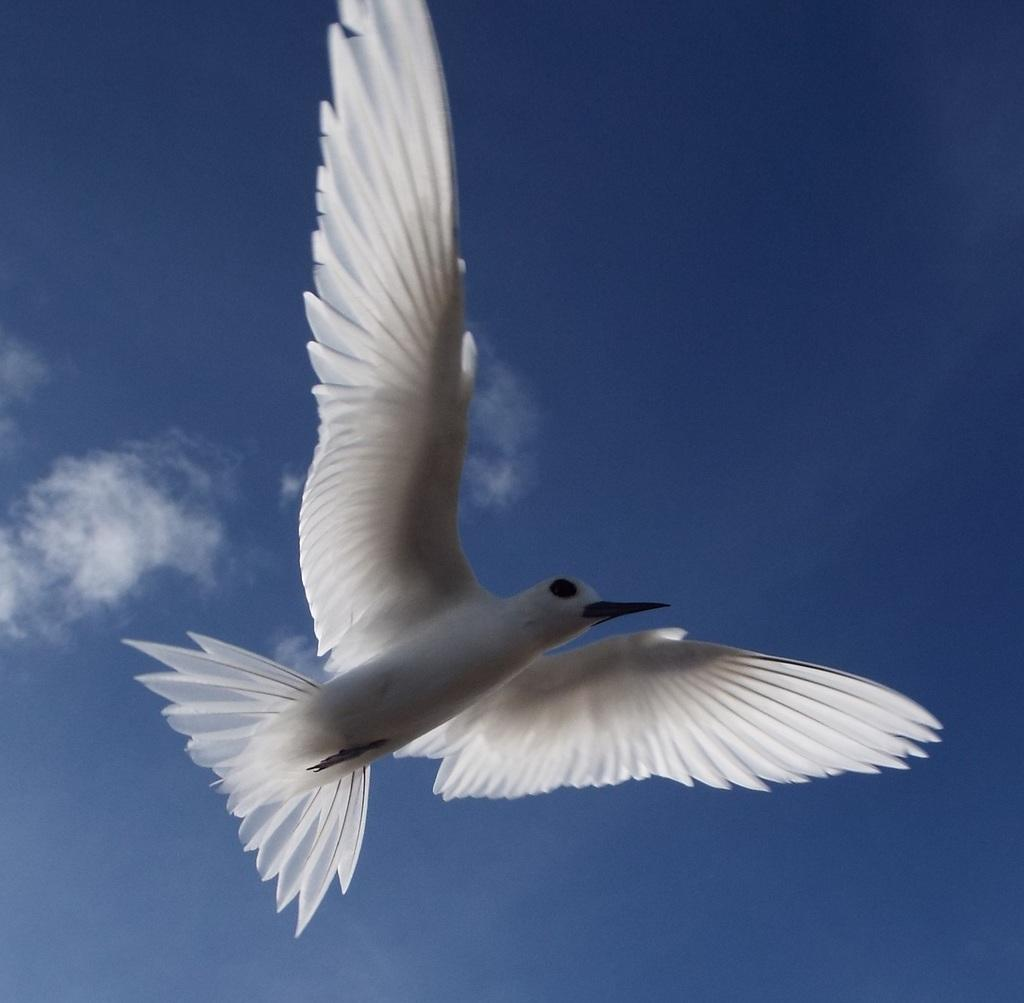What type of animal can be seen in the image? There is a bird in the image. What is the bird doing in the image? The bird is flying. What color is the bird in the image? The bird is white in color. What is the primary setting of the image? The image depicts the sky. What type of grain can be seen growing in the image? There is no grain present in the image; it features a bird flying in the sky. How many stars are visible in the image? The image does not depict any stars; it only shows a bird flying in the sky. 